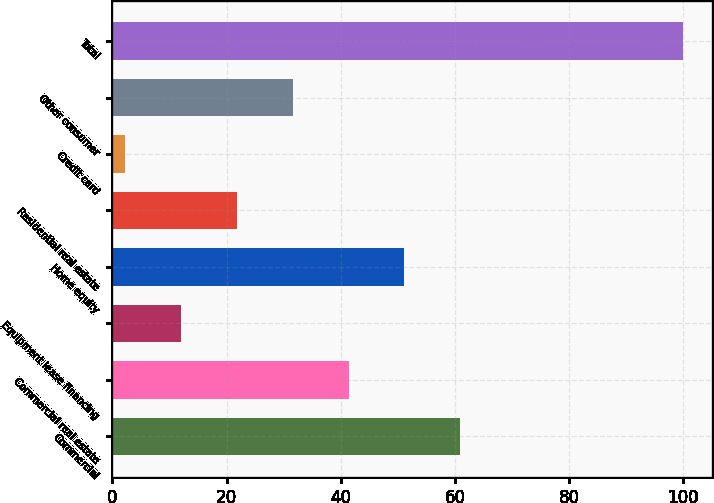Convert chart to OTSL. <chart><loc_0><loc_0><loc_500><loc_500><bar_chart><fcel>Commercial<fcel>Commercial real estate<fcel>Equipment lease financing<fcel>Home equity<fcel>Residential real estate<fcel>Credit card<fcel>Other consumer<fcel>Total<nl><fcel>60.92<fcel>41.38<fcel>12.07<fcel>51.15<fcel>21.84<fcel>2.3<fcel>31.61<fcel>100<nl></chart> 